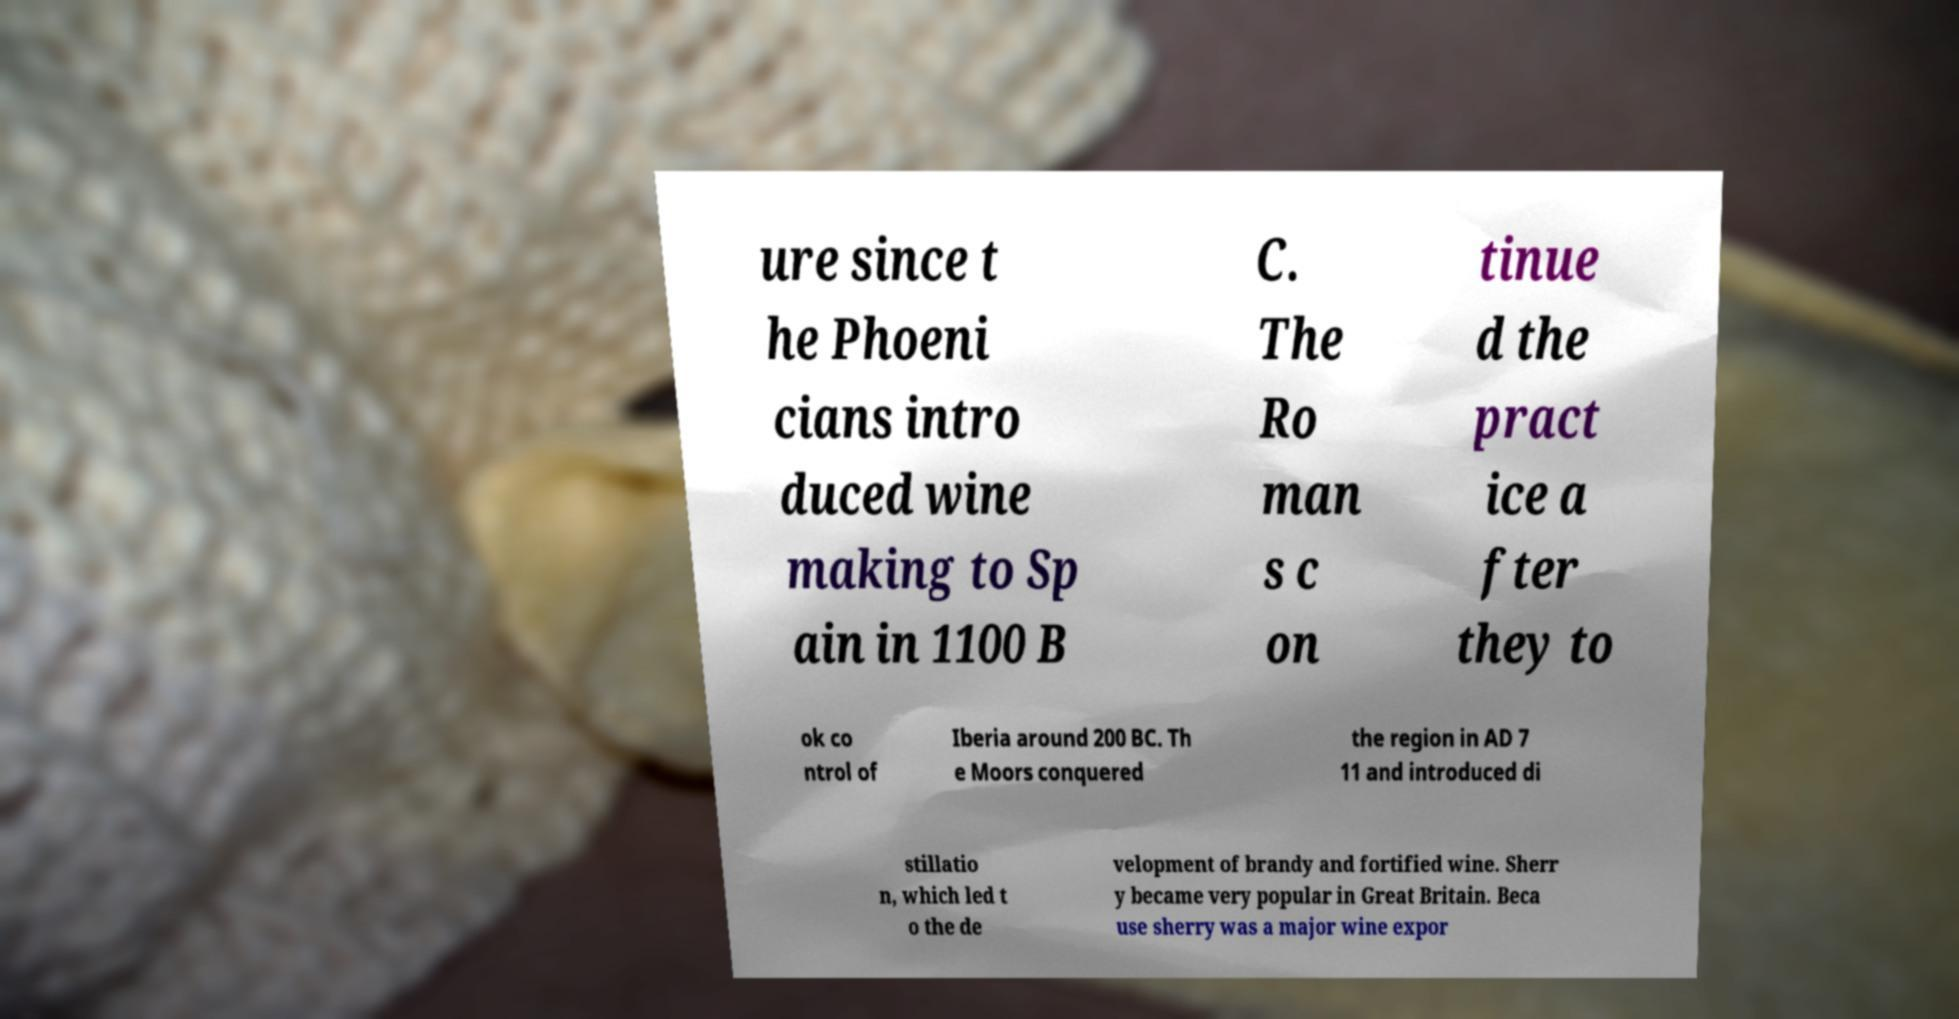Please read and relay the text visible in this image. What does it say? ure since t he Phoeni cians intro duced wine making to Sp ain in 1100 B C. The Ro man s c on tinue d the pract ice a fter they to ok co ntrol of Iberia around 200 BC. Th e Moors conquered the region in AD 7 11 and introduced di stillatio n, which led t o the de velopment of brandy and fortified wine. Sherr y became very popular in Great Britain. Beca use sherry was a major wine expor 